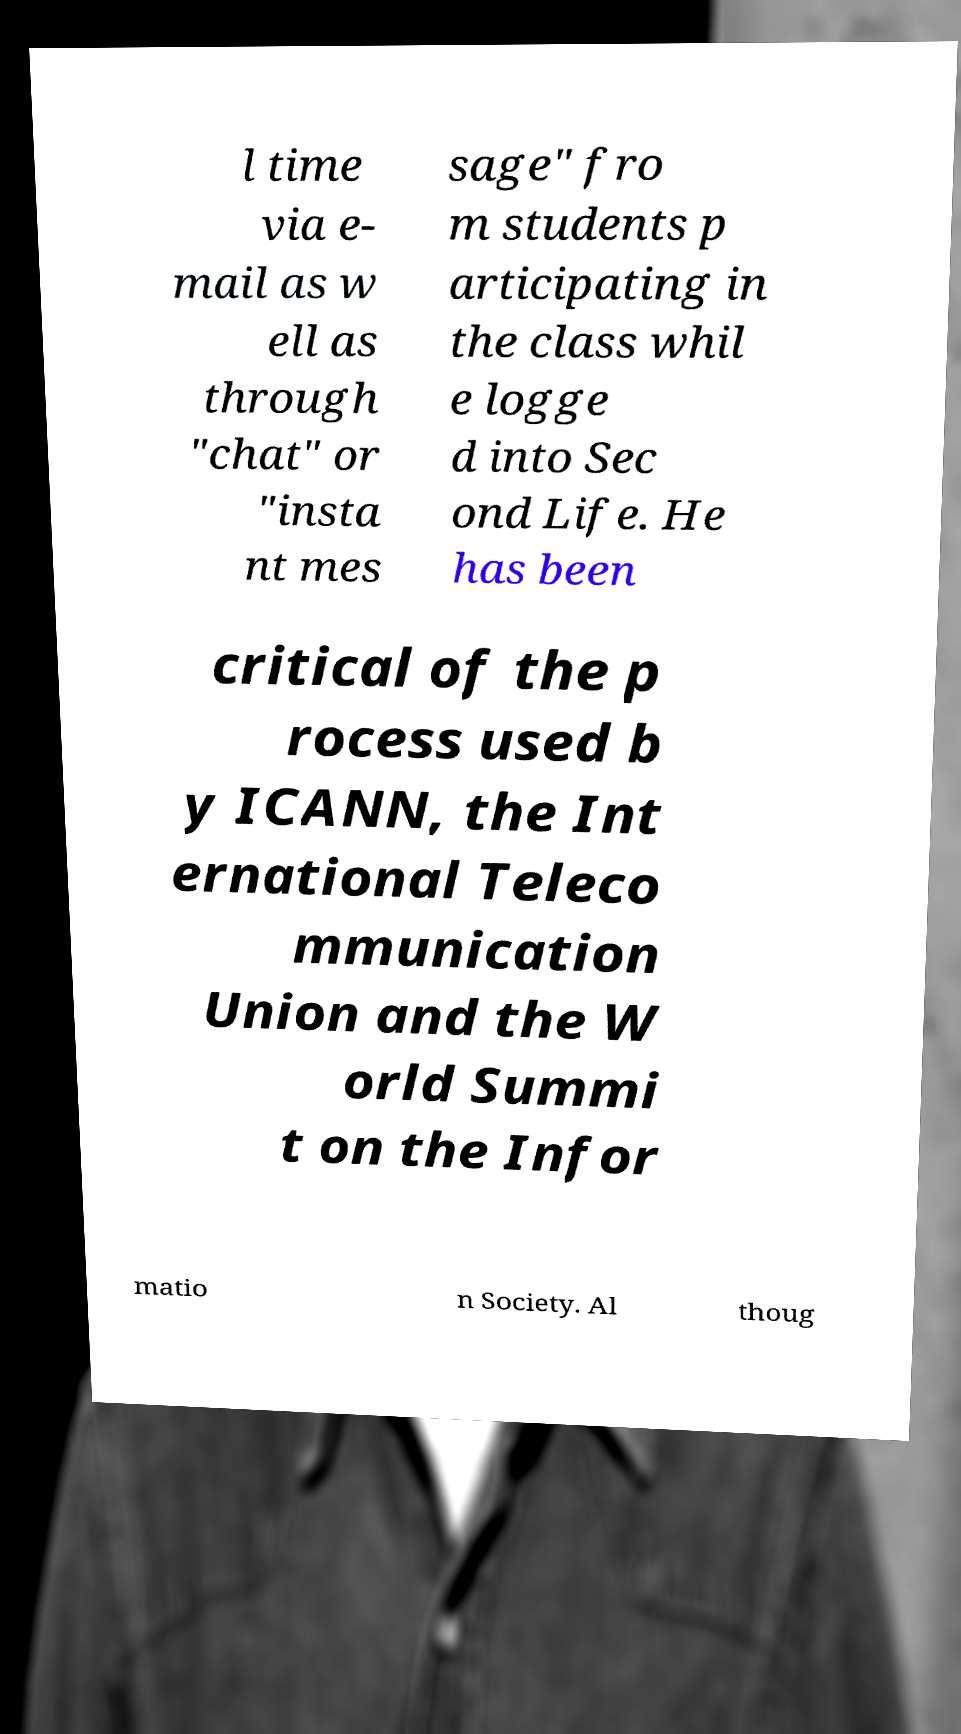Please identify and transcribe the text found in this image. l time via e- mail as w ell as through "chat" or "insta nt mes sage" fro m students p articipating in the class whil e logge d into Sec ond Life. He has been critical of the p rocess used b y ICANN, the Int ernational Teleco mmunication Union and the W orld Summi t on the Infor matio n Society. Al thoug 